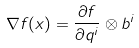<formula> <loc_0><loc_0><loc_500><loc_500>\nabla f ( x ) = \frac { \partial f } { \partial q ^ { i } } \otimes b ^ { i }</formula> 